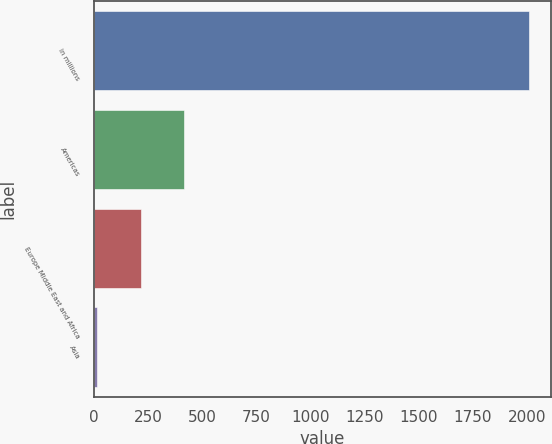Convert chart. <chart><loc_0><loc_0><loc_500><loc_500><bar_chart><fcel>in millions<fcel>Americas<fcel>Europe Middle East and Africa<fcel>Asia<nl><fcel>2012<fcel>415.2<fcel>215.6<fcel>16<nl></chart> 